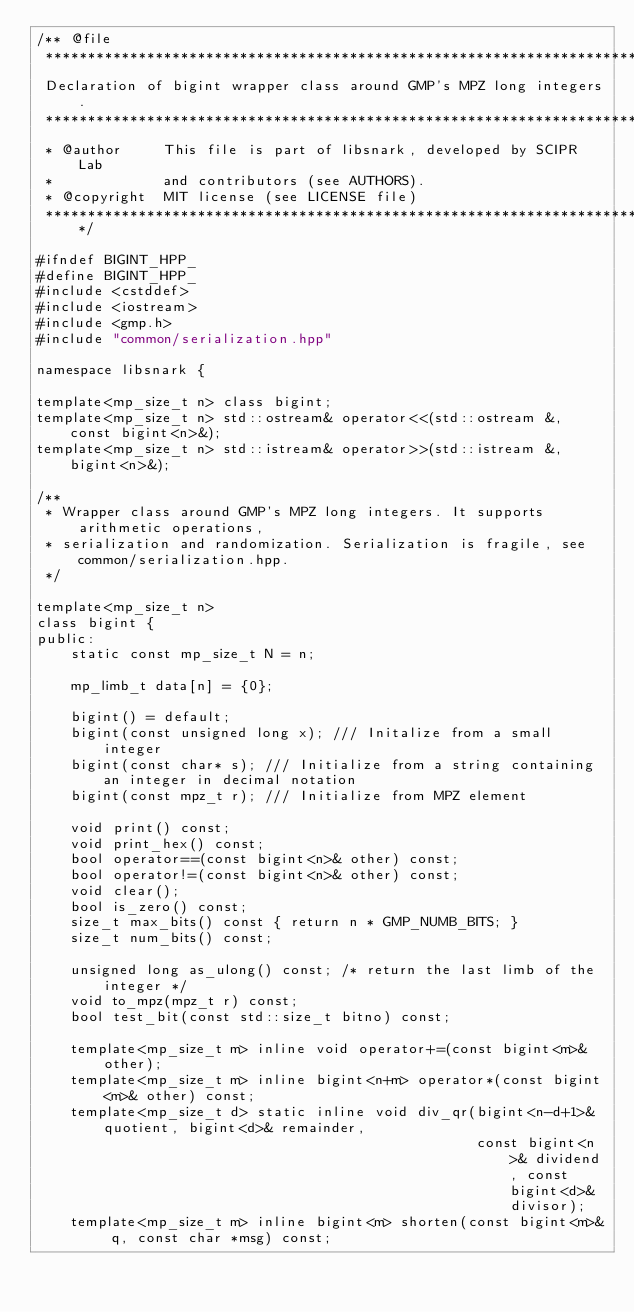<code> <loc_0><loc_0><loc_500><loc_500><_C++_>/** @file
 *****************************************************************************
 Declaration of bigint wrapper class around GMP's MPZ long integers.
 *****************************************************************************
 * @author     This file is part of libsnark, developed by SCIPR Lab
 *             and contributors (see AUTHORS).
 * @copyright  MIT license (see LICENSE file)
 *****************************************************************************/

#ifndef BIGINT_HPP_
#define BIGINT_HPP_
#include <cstddef>
#include <iostream>
#include <gmp.h>
#include "common/serialization.hpp"

namespace libsnark {

template<mp_size_t n> class bigint;
template<mp_size_t n> std::ostream& operator<<(std::ostream &, const bigint<n>&);
template<mp_size_t n> std::istream& operator>>(std::istream &, bigint<n>&);

/**
 * Wrapper class around GMP's MPZ long integers. It supports arithmetic operations,
 * serialization and randomization. Serialization is fragile, see common/serialization.hpp.
 */

template<mp_size_t n>
class bigint {
public:
    static const mp_size_t N = n;

    mp_limb_t data[n] = {0};

    bigint() = default;
    bigint(const unsigned long x); /// Initalize from a small integer
    bigint(const char* s); /// Initialize from a string containing an integer in decimal notation
    bigint(const mpz_t r); /// Initialize from MPZ element

    void print() const;
    void print_hex() const;
    bool operator==(const bigint<n>& other) const;
    bool operator!=(const bigint<n>& other) const;
    void clear();
    bool is_zero() const;
    size_t max_bits() const { return n * GMP_NUMB_BITS; }
    size_t num_bits() const;

    unsigned long as_ulong() const; /* return the last limb of the integer */
    void to_mpz(mpz_t r) const;
    bool test_bit(const std::size_t bitno) const;

    template<mp_size_t m> inline void operator+=(const bigint<m>& other);
    template<mp_size_t m> inline bigint<n+m> operator*(const bigint<m>& other) const;
    template<mp_size_t d> static inline void div_qr(bigint<n-d+1>& quotient, bigint<d>& remainder,
                                                    const bigint<n>& dividend, const bigint<d>& divisor);
    template<mp_size_t m> inline bigint<m> shorten(const bigint<m>& q, const char *msg) const;
</code> 